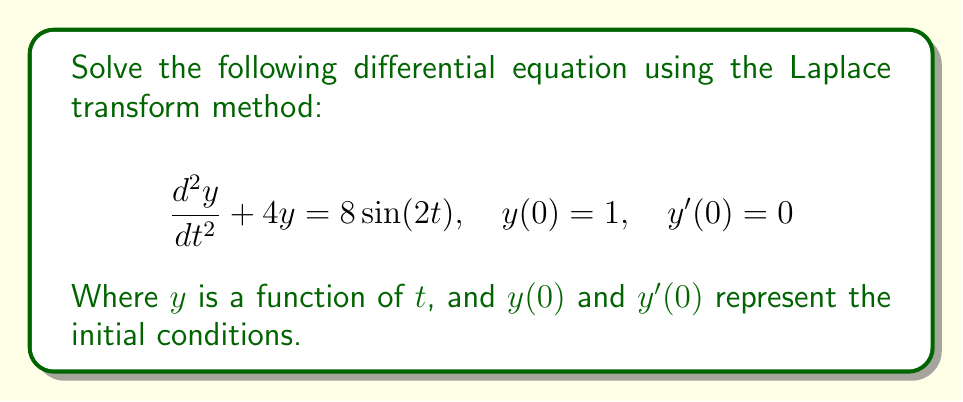Solve this math problem. To solve this differential equation using the Laplace transform method, we'll follow these steps:

1. Take the Laplace transform of both sides of the equation:
   $$\mathcal{L}\left\{\frac{d^2y}{dt^2} + 4y\right\} = \mathcal{L}\{8\sin(2t)\}$$

2. Use the Laplace transform properties:
   $$s^2Y(s) - sy(0) - y'(0) + 4Y(s) = \frac{16}{s^2 + 4}$$
   Where $Y(s) = \mathcal{L}\{y(t)\}$

3. Substitute the initial conditions $y(0) = 1$ and $y'(0) = 0$:
   $$s^2Y(s) - s + 4Y(s) = \frac{16}{s^2 + 4}$$

4. Simplify and solve for $Y(s)$:
   $$(s^2 + 4)Y(s) = \frac{16}{s^2 + 4} + s$$
   $$Y(s) = \frac{16}{(s^2 + 4)^2} + \frac{s}{s^2 + 4}$$

5. Decompose the fraction:
   $$Y(s) = \frac{4}{s^2 + 4} - \frac{4}{(s^2 + 4)^2} + \frac{s}{s^2 + 4}$$

6. Take the inverse Laplace transform:
   $$y(t) = 2\sin(2t) - t\cos(2t) + \cos(2t)$$

This is the solution to the given differential equation.
Answer: $y(t) = 2\sin(2t) - t\cos(2t) + \cos(2t)$ 